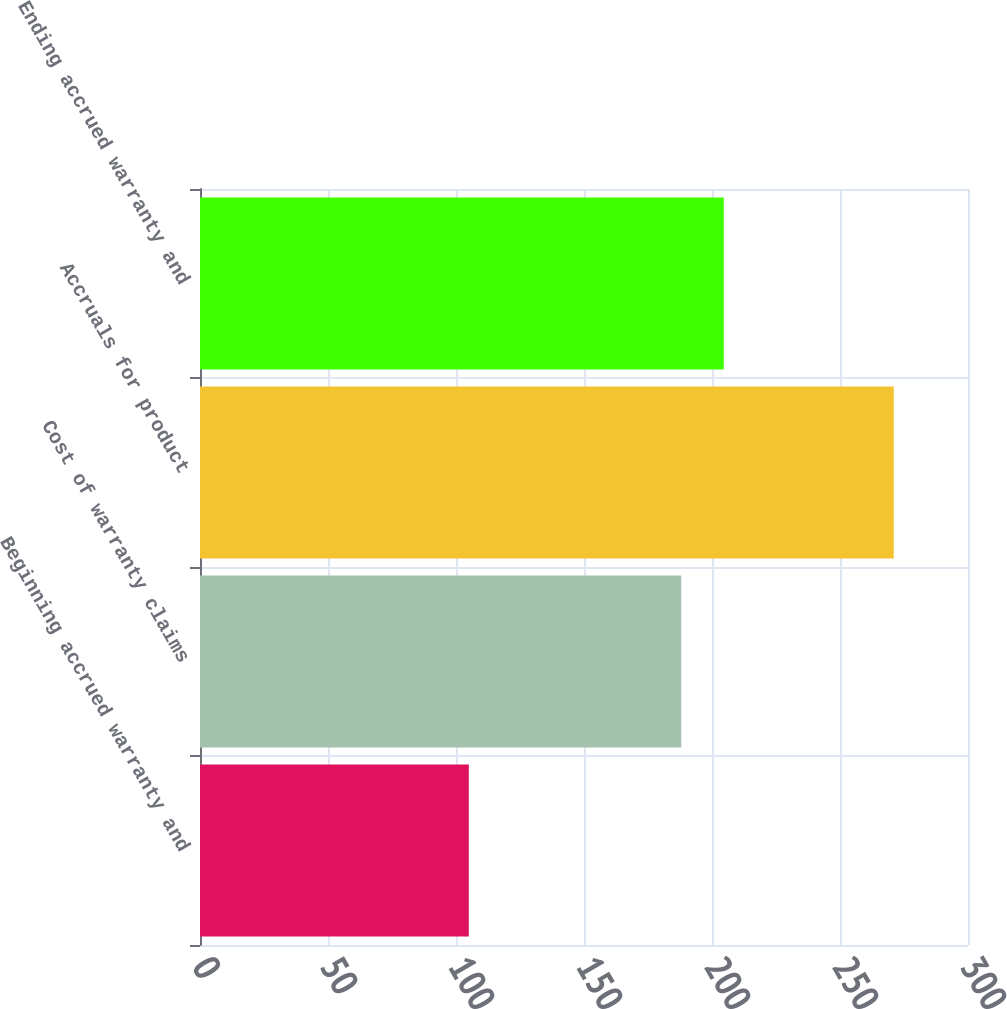Convert chart. <chart><loc_0><loc_0><loc_500><loc_500><bar_chart><fcel>Beginning accrued warranty and<fcel>Cost of warranty claims<fcel>Accruals for product<fcel>Ending accrued warranty and<nl><fcel>105<fcel>188<fcel>271<fcel>204.6<nl></chart> 